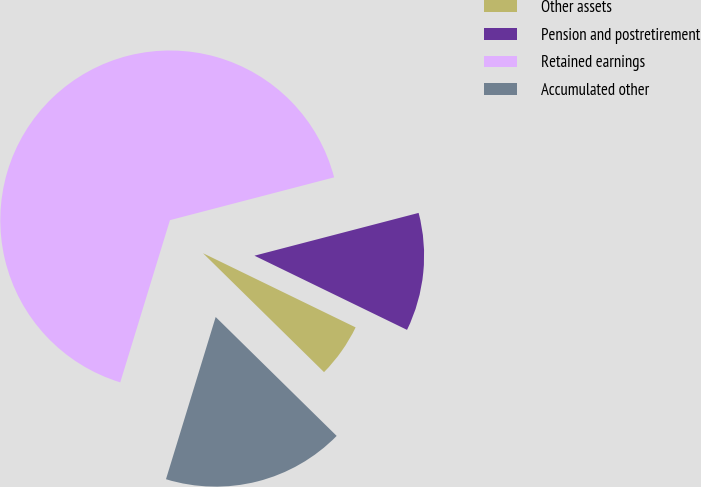<chart> <loc_0><loc_0><loc_500><loc_500><pie_chart><fcel>Other assets<fcel>Pension and postretirement<fcel>Retained earnings<fcel>Accumulated other<nl><fcel>5.16%<fcel>11.26%<fcel>66.21%<fcel>17.37%<nl></chart> 